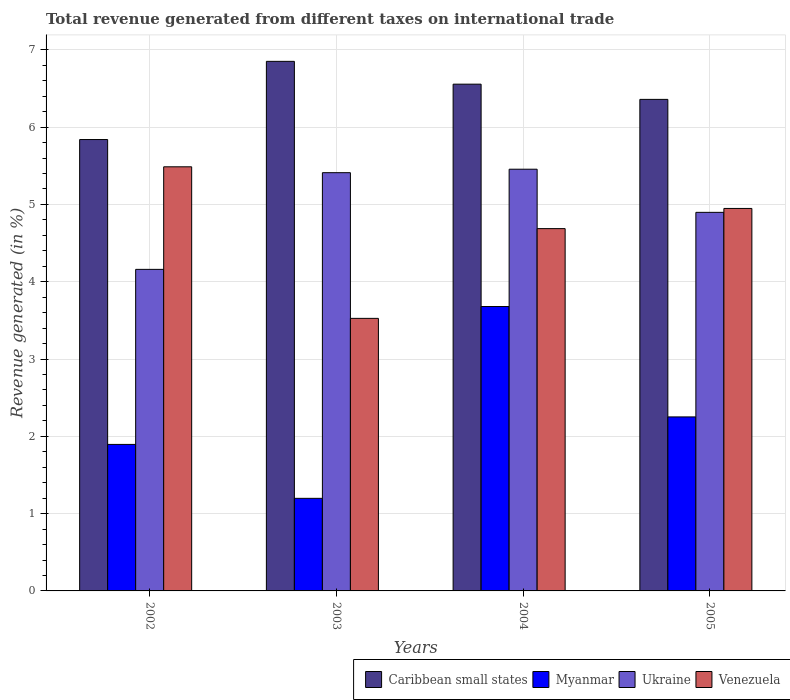How many different coloured bars are there?
Offer a terse response. 4. Are the number of bars on each tick of the X-axis equal?
Provide a succinct answer. Yes. What is the label of the 2nd group of bars from the left?
Keep it short and to the point. 2003. What is the total revenue generated in Ukraine in 2002?
Your answer should be very brief. 4.16. Across all years, what is the maximum total revenue generated in Ukraine?
Offer a terse response. 5.46. Across all years, what is the minimum total revenue generated in Venezuela?
Keep it short and to the point. 3.53. In which year was the total revenue generated in Venezuela maximum?
Ensure brevity in your answer.  2002. In which year was the total revenue generated in Venezuela minimum?
Provide a short and direct response. 2003. What is the total total revenue generated in Ukraine in the graph?
Give a very brief answer. 19.92. What is the difference between the total revenue generated in Venezuela in 2002 and that in 2003?
Provide a succinct answer. 1.96. What is the difference between the total revenue generated in Myanmar in 2003 and the total revenue generated in Venezuela in 2004?
Offer a very short reply. -3.49. What is the average total revenue generated in Myanmar per year?
Provide a short and direct response. 2.26. In the year 2002, what is the difference between the total revenue generated in Caribbean small states and total revenue generated in Venezuela?
Your answer should be very brief. 0.35. In how many years, is the total revenue generated in Myanmar greater than 4.2 %?
Offer a very short reply. 0. What is the ratio of the total revenue generated in Myanmar in 2002 to that in 2004?
Ensure brevity in your answer.  0.52. What is the difference between the highest and the second highest total revenue generated in Myanmar?
Give a very brief answer. 1.43. What is the difference between the highest and the lowest total revenue generated in Venezuela?
Ensure brevity in your answer.  1.96. What does the 1st bar from the left in 2004 represents?
Provide a succinct answer. Caribbean small states. What does the 4th bar from the right in 2003 represents?
Your response must be concise. Caribbean small states. How many years are there in the graph?
Give a very brief answer. 4. What is the difference between two consecutive major ticks on the Y-axis?
Your answer should be compact. 1. Does the graph contain any zero values?
Provide a succinct answer. No. How are the legend labels stacked?
Your answer should be very brief. Horizontal. What is the title of the graph?
Provide a succinct answer. Total revenue generated from different taxes on international trade. What is the label or title of the X-axis?
Ensure brevity in your answer.  Years. What is the label or title of the Y-axis?
Provide a succinct answer. Revenue generated (in %). What is the Revenue generated (in %) in Caribbean small states in 2002?
Give a very brief answer. 5.84. What is the Revenue generated (in %) of Myanmar in 2002?
Provide a short and direct response. 1.9. What is the Revenue generated (in %) in Ukraine in 2002?
Ensure brevity in your answer.  4.16. What is the Revenue generated (in %) of Venezuela in 2002?
Your answer should be compact. 5.49. What is the Revenue generated (in %) in Caribbean small states in 2003?
Give a very brief answer. 6.85. What is the Revenue generated (in %) of Myanmar in 2003?
Offer a very short reply. 1.2. What is the Revenue generated (in %) in Ukraine in 2003?
Your response must be concise. 5.41. What is the Revenue generated (in %) of Venezuela in 2003?
Make the answer very short. 3.53. What is the Revenue generated (in %) in Caribbean small states in 2004?
Provide a succinct answer. 6.56. What is the Revenue generated (in %) in Myanmar in 2004?
Make the answer very short. 3.68. What is the Revenue generated (in %) in Ukraine in 2004?
Offer a terse response. 5.46. What is the Revenue generated (in %) of Venezuela in 2004?
Give a very brief answer. 4.69. What is the Revenue generated (in %) of Caribbean small states in 2005?
Provide a short and direct response. 6.36. What is the Revenue generated (in %) in Myanmar in 2005?
Make the answer very short. 2.25. What is the Revenue generated (in %) of Ukraine in 2005?
Ensure brevity in your answer.  4.9. What is the Revenue generated (in %) of Venezuela in 2005?
Give a very brief answer. 4.95. Across all years, what is the maximum Revenue generated (in %) in Caribbean small states?
Offer a terse response. 6.85. Across all years, what is the maximum Revenue generated (in %) in Myanmar?
Your answer should be very brief. 3.68. Across all years, what is the maximum Revenue generated (in %) of Ukraine?
Keep it short and to the point. 5.46. Across all years, what is the maximum Revenue generated (in %) in Venezuela?
Your response must be concise. 5.49. Across all years, what is the minimum Revenue generated (in %) in Caribbean small states?
Provide a short and direct response. 5.84. Across all years, what is the minimum Revenue generated (in %) of Myanmar?
Keep it short and to the point. 1.2. Across all years, what is the minimum Revenue generated (in %) of Ukraine?
Give a very brief answer. 4.16. Across all years, what is the minimum Revenue generated (in %) in Venezuela?
Make the answer very short. 3.53. What is the total Revenue generated (in %) in Caribbean small states in the graph?
Provide a short and direct response. 25.6. What is the total Revenue generated (in %) of Myanmar in the graph?
Your response must be concise. 9.02. What is the total Revenue generated (in %) of Ukraine in the graph?
Offer a very short reply. 19.92. What is the total Revenue generated (in %) in Venezuela in the graph?
Keep it short and to the point. 18.65. What is the difference between the Revenue generated (in %) of Caribbean small states in 2002 and that in 2003?
Your answer should be very brief. -1.01. What is the difference between the Revenue generated (in %) in Myanmar in 2002 and that in 2003?
Your answer should be compact. 0.7. What is the difference between the Revenue generated (in %) in Ukraine in 2002 and that in 2003?
Keep it short and to the point. -1.25. What is the difference between the Revenue generated (in %) of Venezuela in 2002 and that in 2003?
Your answer should be compact. 1.96. What is the difference between the Revenue generated (in %) of Caribbean small states in 2002 and that in 2004?
Ensure brevity in your answer.  -0.72. What is the difference between the Revenue generated (in %) in Myanmar in 2002 and that in 2004?
Provide a short and direct response. -1.78. What is the difference between the Revenue generated (in %) of Ukraine in 2002 and that in 2004?
Ensure brevity in your answer.  -1.3. What is the difference between the Revenue generated (in %) of Venezuela in 2002 and that in 2004?
Offer a terse response. 0.8. What is the difference between the Revenue generated (in %) of Caribbean small states in 2002 and that in 2005?
Make the answer very short. -0.52. What is the difference between the Revenue generated (in %) in Myanmar in 2002 and that in 2005?
Keep it short and to the point. -0.36. What is the difference between the Revenue generated (in %) of Ukraine in 2002 and that in 2005?
Offer a terse response. -0.74. What is the difference between the Revenue generated (in %) of Venezuela in 2002 and that in 2005?
Offer a very short reply. 0.54. What is the difference between the Revenue generated (in %) in Caribbean small states in 2003 and that in 2004?
Make the answer very short. 0.3. What is the difference between the Revenue generated (in %) in Myanmar in 2003 and that in 2004?
Provide a succinct answer. -2.48. What is the difference between the Revenue generated (in %) in Ukraine in 2003 and that in 2004?
Make the answer very short. -0.04. What is the difference between the Revenue generated (in %) in Venezuela in 2003 and that in 2004?
Your answer should be compact. -1.16. What is the difference between the Revenue generated (in %) in Caribbean small states in 2003 and that in 2005?
Provide a short and direct response. 0.49. What is the difference between the Revenue generated (in %) of Myanmar in 2003 and that in 2005?
Make the answer very short. -1.05. What is the difference between the Revenue generated (in %) of Ukraine in 2003 and that in 2005?
Your response must be concise. 0.51. What is the difference between the Revenue generated (in %) of Venezuela in 2003 and that in 2005?
Make the answer very short. -1.42. What is the difference between the Revenue generated (in %) in Caribbean small states in 2004 and that in 2005?
Your answer should be very brief. 0.2. What is the difference between the Revenue generated (in %) of Myanmar in 2004 and that in 2005?
Ensure brevity in your answer.  1.43. What is the difference between the Revenue generated (in %) in Ukraine in 2004 and that in 2005?
Your answer should be compact. 0.56. What is the difference between the Revenue generated (in %) of Venezuela in 2004 and that in 2005?
Provide a succinct answer. -0.26. What is the difference between the Revenue generated (in %) of Caribbean small states in 2002 and the Revenue generated (in %) of Myanmar in 2003?
Ensure brevity in your answer.  4.64. What is the difference between the Revenue generated (in %) in Caribbean small states in 2002 and the Revenue generated (in %) in Ukraine in 2003?
Ensure brevity in your answer.  0.43. What is the difference between the Revenue generated (in %) in Caribbean small states in 2002 and the Revenue generated (in %) in Venezuela in 2003?
Ensure brevity in your answer.  2.31. What is the difference between the Revenue generated (in %) in Myanmar in 2002 and the Revenue generated (in %) in Ukraine in 2003?
Provide a short and direct response. -3.52. What is the difference between the Revenue generated (in %) in Myanmar in 2002 and the Revenue generated (in %) in Venezuela in 2003?
Ensure brevity in your answer.  -1.63. What is the difference between the Revenue generated (in %) in Ukraine in 2002 and the Revenue generated (in %) in Venezuela in 2003?
Your response must be concise. 0.63. What is the difference between the Revenue generated (in %) of Caribbean small states in 2002 and the Revenue generated (in %) of Myanmar in 2004?
Ensure brevity in your answer.  2.16. What is the difference between the Revenue generated (in %) in Caribbean small states in 2002 and the Revenue generated (in %) in Ukraine in 2004?
Offer a terse response. 0.38. What is the difference between the Revenue generated (in %) of Caribbean small states in 2002 and the Revenue generated (in %) of Venezuela in 2004?
Your answer should be very brief. 1.15. What is the difference between the Revenue generated (in %) of Myanmar in 2002 and the Revenue generated (in %) of Ukraine in 2004?
Give a very brief answer. -3.56. What is the difference between the Revenue generated (in %) in Myanmar in 2002 and the Revenue generated (in %) in Venezuela in 2004?
Keep it short and to the point. -2.79. What is the difference between the Revenue generated (in %) of Ukraine in 2002 and the Revenue generated (in %) of Venezuela in 2004?
Provide a short and direct response. -0.53. What is the difference between the Revenue generated (in %) in Caribbean small states in 2002 and the Revenue generated (in %) in Myanmar in 2005?
Offer a terse response. 3.59. What is the difference between the Revenue generated (in %) in Caribbean small states in 2002 and the Revenue generated (in %) in Ukraine in 2005?
Your answer should be compact. 0.94. What is the difference between the Revenue generated (in %) in Caribbean small states in 2002 and the Revenue generated (in %) in Venezuela in 2005?
Provide a succinct answer. 0.89. What is the difference between the Revenue generated (in %) of Myanmar in 2002 and the Revenue generated (in %) of Ukraine in 2005?
Offer a very short reply. -3. What is the difference between the Revenue generated (in %) in Myanmar in 2002 and the Revenue generated (in %) in Venezuela in 2005?
Give a very brief answer. -3.05. What is the difference between the Revenue generated (in %) in Ukraine in 2002 and the Revenue generated (in %) in Venezuela in 2005?
Ensure brevity in your answer.  -0.79. What is the difference between the Revenue generated (in %) of Caribbean small states in 2003 and the Revenue generated (in %) of Myanmar in 2004?
Make the answer very short. 3.17. What is the difference between the Revenue generated (in %) in Caribbean small states in 2003 and the Revenue generated (in %) in Ukraine in 2004?
Your answer should be very brief. 1.4. What is the difference between the Revenue generated (in %) in Caribbean small states in 2003 and the Revenue generated (in %) in Venezuela in 2004?
Your response must be concise. 2.16. What is the difference between the Revenue generated (in %) of Myanmar in 2003 and the Revenue generated (in %) of Ukraine in 2004?
Give a very brief answer. -4.26. What is the difference between the Revenue generated (in %) of Myanmar in 2003 and the Revenue generated (in %) of Venezuela in 2004?
Offer a terse response. -3.49. What is the difference between the Revenue generated (in %) of Ukraine in 2003 and the Revenue generated (in %) of Venezuela in 2004?
Provide a short and direct response. 0.72. What is the difference between the Revenue generated (in %) in Caribbean small states in 2003 and the Revenue generated (in %) in Myanmar in 2005?
Provide a short and direct response. 4.6. What is the difference between the Revenue generated (in %) in Caribbean small states in 2003 and the Revenue generated (in %) in Ukraine in 2005?
Keep it short and to the point. 1.95. What is the difference between the Revenue generated (in %) of Caribbean small states in 2003 and the Revenue generated (in %) of Venezuela in 2005?
Provide a short and direct response. 1.9. What is the difference between the Revenue generated (in %) of Myanmar in 2003 and the Revenue generated (in %) of Ukraine in 2005?
Your response must be concise. -3.7. What is the difference between the Revenue generated (in %) in Myanmar in 2003 and the Revenue generated (in %) in Venezuela in 2005?
Make the answer very short. -3.75. What is the difference between the Revenue generated (in %) in Ukraine in 2003 and the Revenue generated (in %) in Venezuela in 2005?
Provide a short and direct response. 0.46. What is the difference between the Revenue generated (in %) of Caribbean small states in 2004 and the Revenue generated (in %) of Myanmar in 2005?
Ensure brevity in your answer.  4.3. What is the difference between the Revenue generated (in %) in Caribbean small states in 2004 and the Revenue generated (in %) in Ukraine in 2005?
Provide a short and direct response. 1.66. What is the difference between the Revenue generated (in %) in Caribbean small states in 2004 and the Revenue generated (in %) in Venezuela in 2005?
Ensure brevity in your answer.  1.61. What is the difference between the Revenue generated (in %) of Myanmar in 2004 and the Revenue generated (in %) of Ukraine in 2005?
Your response must be concise. -1.22. What is the difference between the Revenue generated (in %) in Myanmar in 2004 and the Revenue generated (in %) in Venezuela in 2005?
Keep it short and to the point. -1.27. What is the difference between the Revenue generated (in %) in Ukraine in 2004 and the Revenue generated (in %) in Venezuela in 2005?
Offer a terse response. 0.51. What is the average Revenue generated (in %) in Caribbean small states per year?
Offer a terse response. 6.4. What is the average Revenue generated (in %) of Myanmar per year?
Your answer should be compact. 2.26. What is the average Revenue generated (in %) in Ukraine per year?
Ensure brevity in your answer.  4.98. What is the average Revenue generated (in %) of Venezuela per year?
Make the answer very short. 4.66. In the year 2002, what is the difference between the Revenue generated (in %) in Caribbean small states and Revenue generated (in %) in Myanmar?
Your response must be concise. 3.94. In the year 2002, what is the difference between the Revenue generated (in %) of Caribbean small states and Revenue generated (in %) of Ukraine?
Provide a short and direct response. 1.68. In the year 2002, what is the difference between the Revenue generated (in %) of Caribbean small states and Revenue generated (in %) of Venezuela?
Your response must be concise. 0.35. In the year 2002, what is the difference between the Revenue generated (in %) of Myanmar and Revenue generated (in %) of Ukraine?
Keep it short and to the point. -2.26. In the year 2002, what is the difference between the Revenue generated (in %) in Myanmar and Revenue generated (in %) in Venezuela?
Offer a very short reply. -3.59. In the year 2002, what is the difference between the Revenue generated (in %) of Ukraine and Revenue generated (in %) of Venezuela?
Your answer should be compact. -1.33. In the year 2003, what is the difference between the Revenue generated (in %) of Caribbean small states and Revenue generated (in %) of Myanmar?
Make the answer very short. 5.65. In the year 2003, what is the difference between the Revenue generated (in %) of Caribbean small states and Revenue generated (in %) of Ukraine?
Your answer should be compact. 1.44. In the year 2003, what is the difference between the Revenue generated (in %) of Caribbean small states and Revenue generated (in %) of Venezuela?
Keep it short and to the point. 3.32. In the year 2003, what is the difference between the Revenue generated (in %) in Myanmar and Revenue generated (in %) in Ukraine?
Keep it short and to the point. -4.21. In the year 2003, what is the difference between the Revenue generated (in %) of Myanmar and Revenue generated (in %) of Venezuela?
Give a very brief answer. -2.33. In the year 2003, what is the difference between the Revenue generated (in %) in Ukraine and Revenue generated (in %) in Venezuela?
Your answer should be very brief. 1.88. In the year 2004, what is the difference between the Revenue generated (in %) in Caribbean small states and Revenue generated (in %) in Myanmar?
Offer a terse response. 2.88. In the year 2004, what is the difference between the Revenue generated (in %) in Caribbean small states and Revenue generated (in %) in Ukraine?
Give a very brief answer. 1.1. In the year 2004, what is the difference between the Revenue generated (in %) of Caribbean small states and Revenue generated (in %) of Venezuela?
Provide a short and direct response. 1.87. In the year 2004, what is the difference between the Revenue generated (in %) of Myanmar and Revenue generated (in %) of Ukraine?
Provide a short and direct response. -1.78. In the year 2004, what is the difference between the Revenue generated (in %) of Myanmar and Revenue generated (in %) of Venezuela?
Offer a terse response. -1.01. In the year 2004, what is the difference between the Revenue generated (in %) in Ukraine and Revenue generated (in %) in Venezuela?
Offer a very short reply. 0.77. In the year 2005, what is the difference between the Revenue generated (in %) of Caribbean small states and Revenue generated (in %) of Myanmar?
Provide a short and direct response. 4.11. In the year 2005, what is the difference between the Revenue generated (in %) in Caribbean small states and Revenue generated (in %) in Ukraine?
Provide a short and direct response. 1.46. In the year 2005, what is the difference between the Revenue generated (in %) of Caribbean small states and Revenue generated (in %) of Venezuela?
Make the answer very short. 1.41. In the year 2005, what is the difference between the Revenue generated (in %) in Myanmar and Revenue generated (in %) in Ukraine?
Offer a terse response. -2.65. In the year 2005, what is the difference between the Revenue generated (in %) in Myanmar and Revenue generated (in %) in Venezuela?
Provide a short and direct response. -2.7. In the year 2005, what is the difference between the Revenue generated (in %) in Ukraine and Revenue generated (in %) in Venezuela?
Offer a terse response. -0.05. What is the ratio of the Revenue generated (in %) in Caribbean small states in 2002 to that in 2003?
Your response must be concise. 0.85. What is the ratio of the Revenue generated (in %) of Myanmar in 2002 to that in 2003?
Provide a succinct answer. 1.58. What is the ratio of the Revenue generated (in %) in Ukraine in 2002 to that in 2003?
Your response must be concise. 0.77. What is the ratio of the Revenue generated (in %) of Venezuela in 2002 to that in 2003?
Offer a terse response. 1.56. What is the ratio of the Revenue generated (in %) of Caribbean small states in 2002 to that in 2004?
Your answer should be compact. 0.89. What is the ratio of the Revenue generated (in %) of Myanmar in 2002 to that in 2004?
Make the answer very short. 0.52. What is the ratio of the Revenue generated (in %) of Ukraine in 2002 to that in 2004?
Your answer should be very brief. 0.76. What is the ratio of the Revenue generated (in %) of Venezuela in 2002 to that in 2004?
Make the answer very short. 1.17. What is the ratio of the Revenue generated (in %) in Caribbean small states in 2002 to that in 2005?
Make the answer very short. 0.92. What is the ratio of the Revenue generated (in %) in Myanmar in 2002 to that in 2005?
Provide a succinct answer. 0.84. What is the ratio of the Revenue generated (in %) of Ukraine in 2002 to that in 2005?
Your answer should be very brief. 0.85. What is the ratio of the Revenue generated (in %) of Venezuela in 2002 to that in 2005?
Keep it short and to the point. 1.11. What is the ratio of the Revenue generated (in %) of Caribbean small states in 2003 to that in 2004?
Provide a succinct answer. 1.04. What is the ratio of the Revenue generated (in %) of Myanmar in 2003 to that in 2004?
Your response must be concise. 0.33. What is the ratio of the Revenue generated (in %) in Ukraine in 2003 to that in 2004?
Your response must be concise. 0.99. What is the ratio of the Revenue generated (in %) of Venezuela in 2003 to that in 2004?
Offer a terse response. 0.75. What is the ratio of the Revenue generated (in %) of Caribbean small states in 2003 to that in 2005?
Your response must be concise. 1.08. What is the ratio of the Revenue generated (in %) in Myanmar in 2003 to that in 2005?
Provide a succinct answer. 0.53. What is the ratio of the Revenue generated (in %) in Ukraine in 2003 to that in 2005?
Give a very brief answer. 1.1. What is the ratio of the Revenue generated (in %) in Venezuela in 2003 to that in 2005?
Give a very brief answer. 0.71. What is the ratio of the Revenue generated (in %) of Caribbean small states in 2004 to that in 2005?
Your response must be concise. 1.03. What is the ratio of the Revenue generated (in %) of Myanmar in 2004 to that in 2005?
Offer a terse response. 1.63. What is the ratio of the Revenue generated (in %) in Ukraine in 2004 to that in 2005?
Give a very brief answer. 1.11. What is the ratio of the Revenue generated (in %) of Venezuela in 2004 to that in 2005?
Your response must be concise. 0.95. What is the difference between the highest and the second highest Revenue generated (in %) in Caribbean small states?
Offer a terse response. 0.3. What is the difference between the highest and the second highest Revenue generated (in %) in Myanmar?
Offer a terse response. 1.43. What is the difference between the highest and the second highest Revenue generated (in %) in Ukraine?
Your response must be concise. 0.04. What is the difference between the highest and the second highest Revenue generated (in %) in Venezuela?
Provide a short and direct response. 0.54. What is the difference between the highest and the lowest Revenue generated (in %) in Caribbean small states?
Your answer should be compact. 1.01. What is the difference between the highest and the lowest Revenue generated (in %) of Myanmar?
Make the answer very short. 2.48. What is the difference between the highest and the lowest Revenue generated (in %) in Ukraine?
Ensure brevity in your answer.  1.3. What is the difference between the highest and the lowest Revenue generated (in %) of Venezuela?
Keep it short and to the point. 1.96. 